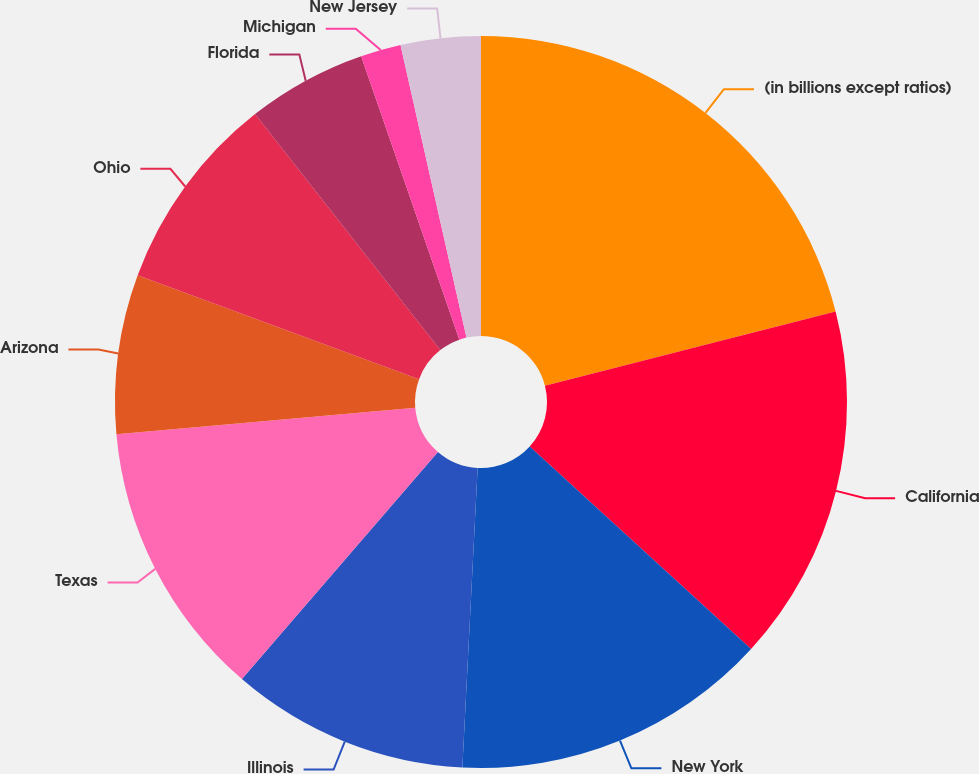Convert chart. <chart><loc_0><loc_0><loc_500><loc_500><pie_chart><fcel>(in billions except ratios)<fcel>California<fcel>New York<fcel>Illinois<fcel>Texas<fcel>Arizona<fcel>Ohio<fcel>Florida<fcel>Michigan<fcel>New Jersey<nl><fcel>21.02%<fcel>15.77%<fcel>14.02%<fcel>10.52%<fcel>12.27%<fcel>7.03%<fcel>8.78%<fcel>5.28%<fcel>1.78%<fcel>3.53%<nl></chart> 